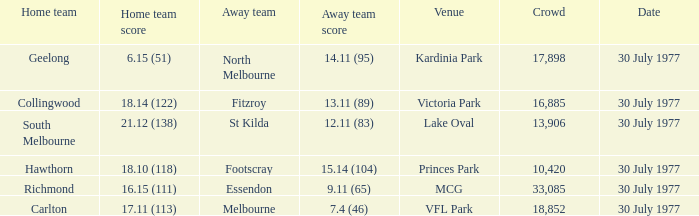What is north melbourne's score as an away side? 14.11 (95). 